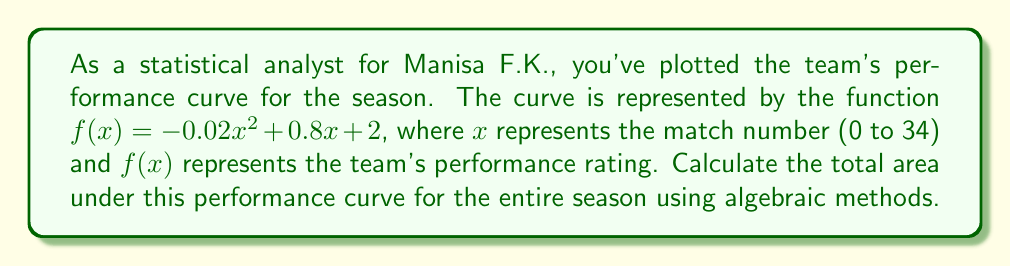Give your solution to this math problem. To calculate the area under the curve, we need to integrate the function $f(x)$ from $x=0$ to $x=34$. Here's the step-by-step process:

1) The integral of $f(x) = -0.02x^2 + 0.8x + 2$ is:

   $$F(x) = \int f(x) dx = -\frac{0.02x^3}{3} + 0.4x^2 + 2x + C$$

2) We need to evaluate this from 0 to 34:

   $$\text{Area} = F(34) - F(0)$$

3) Let's calculate $F(34)$:
   
   $$F(34) = -\frac{0.02(34^3)}{3} + 0.4(34^2) + 2(34)$$
   $$= -261.3333... + 462.4 + 68 = 269.0666...$$

4) Now $F(0)$:
   
   $$F(0) = -\frac{0.02(0^3)}{3} + 0.4(0^2) + 2(0) = 0$$

5) Therefore, the area is:

   $$\text{Area} = 269.0666... - 0 = 269.0666...$$

6) Rounding to two decimal places:

   $$\text{Area} \approx 269.07$$

This represents the total accumulated performance over the season.
Answer: 269.07 